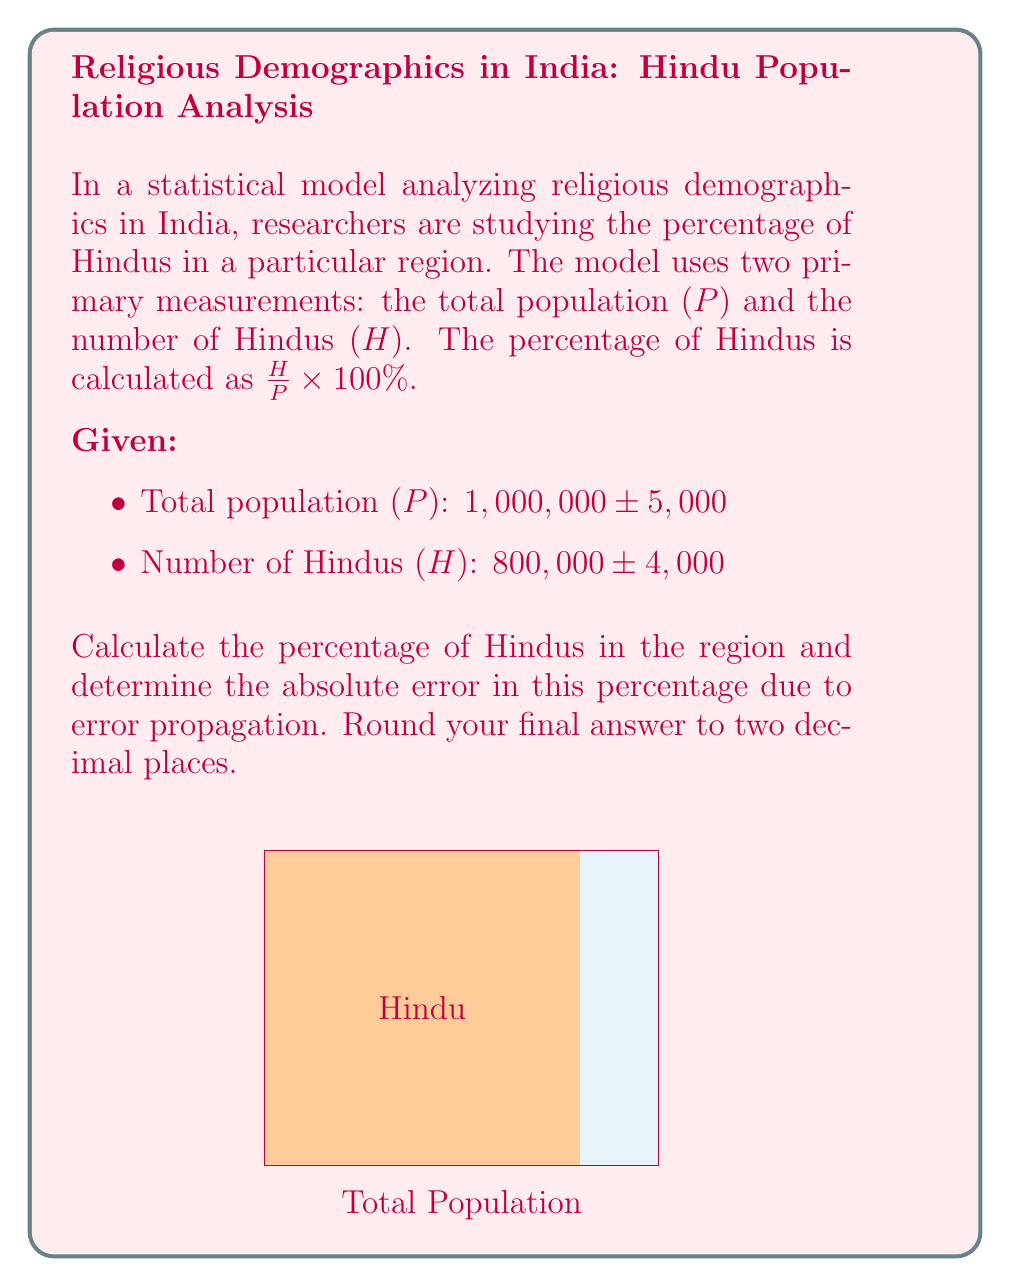Could you help me with this problem? To solve this problem, we'll use error propagation techniques for division and multiplication.

Step 1: Calculate the percentage of Hindus
$$\text{Percentage} = \frac{H}{P} \times 100\% = \frac{800,000}{1,000,000} \times 100\% = 80\%$$

Step 2: Use the error propagation formula for division
For $z = \frac{x}{y}$, the relative error is given by:
$$\frac{\Delta z}{z} = \sqrt{\left(\frac{\Delta x}{x}\right)^2 + \left(\frac{\Delta y}{y}\right)^2}$$

Where:
$\Delta x = 4,000$ (error in H)
$\Delta y = 5,000$ (error in P)
$x = 800,000$ (H)
$y = 1,000,000$ (P)

Step 3: Calculate the relative error
$$\frac{\Delta z}{z} = \sqrt{\left(\frac{4,000}{800,000}\right)^2 + \left(\frac{5,000}{1,000,000}\right)^2}$$
$$= \sqrt{(0.005)^2 + (0.005)^2}$$
$$= \sqrt{0.00005} \approx 0.007071$$

Step 4: Calculate the absolute error in the percentage
Absolute error = Relative error × Percentage
$$\Delta \text{Percentage} = 0.007071 \times 80\% = 0.5657\%$$

Step 5: Round to two decimal places
$$\Delta \text{Percentage} \approx 0.57\%$$

Therefore, the percentage of Hindus in the region is 80% ± 0.57%.
Answer: 80% ± 0.57% 